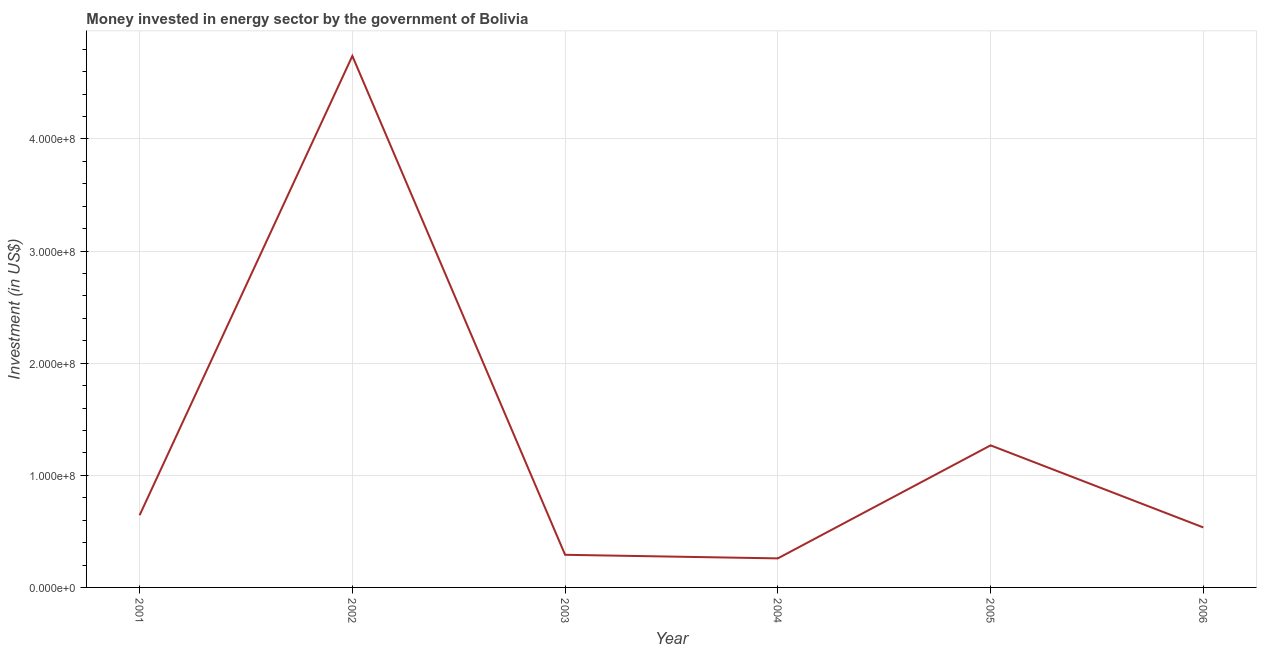What is the investment in energy in 2003?
Provide a succinct answer. 2.91e+07. Across all years, what is the maximum investment in energy?
Make the answer very short. 4.74e+08. Across all years, what is the minimum investment in energy?
Your response must be concise. 2.59e+07. What is the sum of the investment in energy?
Offer a terse response. 7.74e+08. What is the difference between the investment in energy in 2001 and 2002?
Provide a short and direct response. -4.10e+08. What is the average investment in energy per year?
Offer a terse response. 1.29e+08. What is the median investment in energy?
Keep it short and to the point. 5.90e+07. Do a majority of the years between 2004 and 2003 (inclusive) have investment in energy greater than 100000000 US$?
Make the answer very short. No. What is the ratio of the investment in energy in 2001 to that in 2006?
Provide a succinct answer. 1.2. Is the investment in energy in 2002 less than that in 2003?
Offer a terse response. No. Is the difference between the investment in energy in 2003 and 2005 greater than the difference between any two years?
Make the answer very short. No. What is the difference between the highest and the second highest investment in energy?
Give a very brief answer. 3.47e+08. Is the sum of the investment in energy in 2001 and 2003 greater than the maximum investment in energy across all years?
Your answer should be very brief. No. What is the difference between the highest and the lowest investment in energy?
Offer a terse response. 4.48e+08. Does the investment in energy monotonically increase over the years?
Ensure brevity in your answer.  No. How many lines are there?
Ensure brevity in your answer.  1. How many years are there in the graph?
Ensure brevity in your answer.  6. What is the difference between two consecutive major ticks on the Y-axis?
Ensure brevity in your answer.  1.00e+08. What is the title of the graph?
Make the answer very short. Money invested in energy sector by the government of Bolivia. What is the label or title of the X-axis?
Your response must be concise. Year. What is the label or title of the Y-axis?
Your answer should be compact. Investment (in US$). What is the Investment (in US$) of 2001?
Your answer should be compact. 6.44e+07. What is the Investment (in US$) in 2002?
Offer a very short reply. 4.74e+08. What is the Investment (in US$) in 2003?
Offer a terse response. 2.91e+07. What is the Investment (in US$) in 2004?
Keep it short and to the point. 2.59e+07. What is the Investment (in US$) of 2005?
Give a very brief answer. 1.27e+08. What is the Investment (in US$) in 2006?
Offer a terse response. 5.35e+07. What is the difference between the Investment (in US$) in 2001 and 2002?
Provide a succinct answer. -4.10e+08. What is the difference between the Investment (in US$) in 2001 and 2003?
Make the answer very short. 3.53e+07. What is the difference between the Investment (in US$) in 2001 and 2004?
Ensure brevity in your answer.  3.85e+07. What is the difference between the Investment (in US$) in 2001 and 2005?
Offer a very short reply. -6.23e+07. What is the difference between the Investment (in US$) in 2001 and 2006?
Provide a succinct answer. 1.09e+07. What is the difference between the Investment (in US$) in 2002 and 2003?
Offer a very short reply. 4.45e+08. What is the difference between the Investment (in US$) in 2002 and 2004?
Your answer should be very brief. 4.48e+08. What is the difference between the Investment (in US$) in 2002 and 2005?
Your response must be concise. 3.47e+08. What is the difference between the Investment (in US$) in 2002 and 2006?
Your answer should be very brief. 4.20e+08. What is the difference between the Investment (in US$) in 2003 and 2004?
Offer a terse response. 3.20e+06. What is the difference between the Investment (in US$) in 2003 and 2005?
Make the answer very short. -9.76e+07. What is the difference between the Investment (in US$) in 2003 and 2006?
Keep it short and to the point. -2.44e+07. What is the difference between the Investment (in US$) in 2004 and 2005?
Give a very brief answer. -1.01e+08. What is the difference between the Investment (in US$) in 2004 and 2006?
Give a very brief answer. -2.76e+07. What is the difference between the Investment (in US$) in 2005 and 2006?
Offer a terse response. 7.32e+07. What is the ratio of the Investment (in US$) in 2001 to that in 2002?
Offer a very short reply. 0.14. What is the ratio of the Investment (in US$) in 2001 to that in 2003?
Your answer should be compact. 2.21. What is the ratio of the Investment (in US$) in 2001 to that in 2004?
Offer a very short reply. 2.49. What is the ratio of the Investment (in US$) in 2001 to that in 2005?
Make the answer very short. 0.51. What is the ratio of the Investment (in US$) in 2001 to that in 2006?
Provide a succinct answer. 1.2. What is the ratio of the Investment (in US$) in 2002 to that in 2003?
Your answer should be very brief. 16.29. What is the ratio of the Investment (in US$) in 2002 to that in 2004?
Ensure brevity in your answer.  18.3. What is the ratio of the Investment (in US$) in 2002 to that in 2005?
Provide a short and direct response. 3.74. What is the ratio of the Investment (in US$) in 2002 to that in 2006?
Provide a succinct answer. 8.86. What is the ratio of the Investment (in US$) in 2003 to that in 2004?
Keep it short and to the point. 1.12. What is the ratio of the Investment (in US$) in 2003 to that in 2005?
Offer a very short reply. 0.23. What is the ratio of the Investment (in US$) in 2003 to that in 2006?
Provide a short and direct response. 0.54. What is the ratio of the Investment (in US$) in 2004 to that in 2005?
Provide a succinct answer. 0.2. What is the ratio of the Investment (in US$) in 2004 to that in 2006?
Your answer should be compact. 0.48. What is the ratio of the Investment (in US$) in 2005 to that in 2006?
Give a very brief answer. 2.37. 